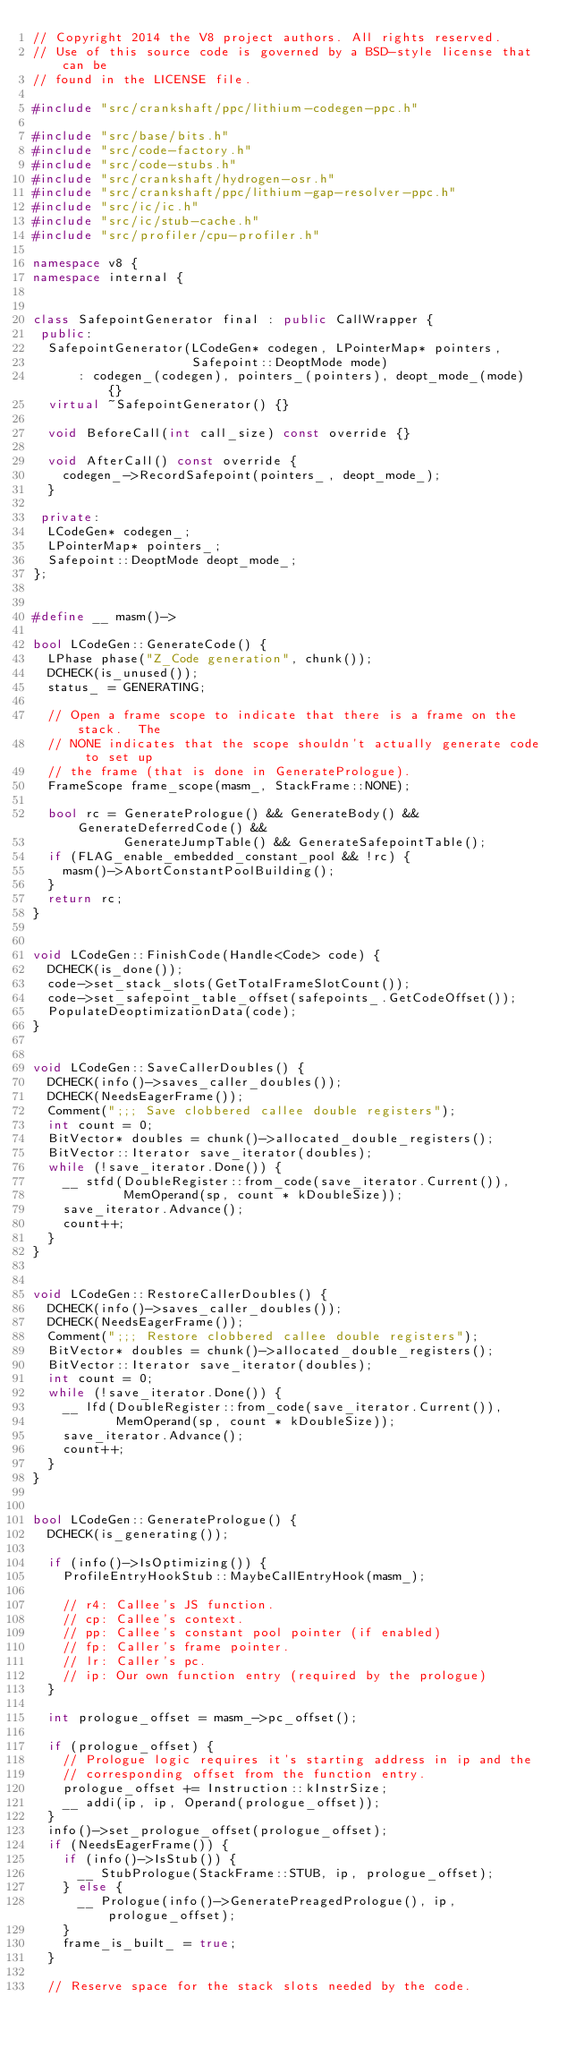Convert code to text. <code><loc_0><loc_0><loc_500><loc_500><_C++_>// Copyright 2014 the V8 project authors. All rights reserved.
// Use of this source code is governed by a BSD-style license that can be
// found in the LICENSE file.

#include "src/crankshaft/ppc/lithium-codegen-ppc.h"

#include "src/base/bits.h"
#include "src/code-factory.h"
#include "src/code-stubs.h"
#include "src/crankshaft/hydrogen-osr.h"
#include "src/crankshaft/ppc/lithium-gap-resolver-ppc.h"
#include "src/ic/ic.h"
#include "src/ic/stub-cache.h"
#include "src/profiler/cpu-profiler.h"

namespace v8 {
namespace internal {


class SafepointGenerator final : public CallWrapper {
 public:
  SafepointGenerator(LCodeGen* codegen, LPointerMap* pointers,
                     Safepoint::DeoptMode mode)
      : codegen_(codegen), pointers_(pointers), deopt_mode_(mode) {}
  virtual ~SafepointGenerator() {}

  void BeforeCall(int call_size) const override {}

  void AfterCall() const override {
    codegen_->RecordSafepoint(pointers_, deopt_mode_);
  }

 private:
  LCodeGen* codegen_;
  LPointerMap* pointers_;
  Safepoint::DeoptMode deopt_mode_;
};


#define __ masm()->

bool LCodeGen::GenerateCode() {
  LPhase phase("Z_Code generation", chunk());
  DCHECK(is_unused());
  status_ = GENERATING;

  // Open a frame scope to indicate that there is a frame on the stack.  The
  // NONE indicates that the scope shouldn't actually generate code to set up
  // the frame (that is done in GeneratePrologue).
  FrameScope frame_scope(masm_, StackFrame::NONE);

  bool rc = GeneratePrologue() && GenerateBody() && GenerateDeferredCode() &&
            GenerateJumpTable() && GenerateSafepointTable();
  if (FLAG_enable_embedded_constant_pool && !rc) {
    masm()->AbortConstantPoolBuilding();
  }
  return rc;
}


void LCodeGen::FinishCode(Handle<Code> code) {
  DCHECK(is_done());
  code->set_stack_slots(GetTotalFrameSlotCount());
  code->set_safepoint_table_offset(safepoints_.GetCodeOffset());
  PopulateDeoptimizationData(code);
}


void LCodeGen::SaveCallerDoubles() {
  DCHECK(info()->saves_caller_doubles());
  DCHECK(NeedsEagerFrame());
  Comment(";;; Save clobbered callee double registers");
  int count = 0;
  BitVector* doubles = chunk()->allocated_double_registers();
  BitVector::Iterator save_iterator(doubles);
  while (!save_iterator.Done()) {
    __ stfd(DoubleRegister::from_code(save_iterator.Current()),
            MemOperand(sp, count * kDoubleSize));
    save_iterator.Advance();
    count++;
  }
}


void LCodeGen::RestoreCallerDoubles() {
  DCHECK(info()->saves_caller_doubles());
  DCHECK(NeedsEagerFrame());
  Comment(";;; Restore clobbered callee double registers");
  BitVector* doubles = chunk()->allocated_double_registers();
  BitVector::Iterator save_iterator(doubles);
  int count = 0;
  while (!save_iterator.Done()) {
    __ lfd(DoubleRegister::from_code(save_iterator.Current()),
           MemOperand(sp, count * kDoubleSize));
    save_iterator.Advance();
    count++;
  }
}


bool LCodeGen::GeneratePrologue() {
  DCHECK(is_generating());

  if (info()->IsOptimizing()) {
    ProfileEntryHookStub::MaybeCallEntryHook(masm_);

    // r4: Callee's JS function.
    // cp: Callee's context.
    // pp: Callee's constant pool pointer (if enabled)
    // fp: Caller's frame pointer.
    // lr: Caller's pc.
    // ip: Our own function entry (required by the prologue)
  }

  int prologue_offset = masm_->pc_offset();

  if (prologue_offset) {
    // Prologue logic requires it's starting address in ip and the
    // corresponding offset from the function entry.
    prologue_offset += Instruction::kInstrSize;
    __ addi(ip, ip, Operand(prologue_offset));
  }
  info()->set_prologue_offset(prologue_offset);
  if (NeedsEagerFrame()) {
    if (info()->IsStub()) {
      __ StubPrologue(StackFrame::STUB, ip, prologue_offset);
    } else {
      __ Prologue(info()->GeneratePreagedPrologue(), ip, prologue_offset);
    }
    frame_is_built_ = true;
  }

  // Reserve space for the stack slots needed by the code.</code> 